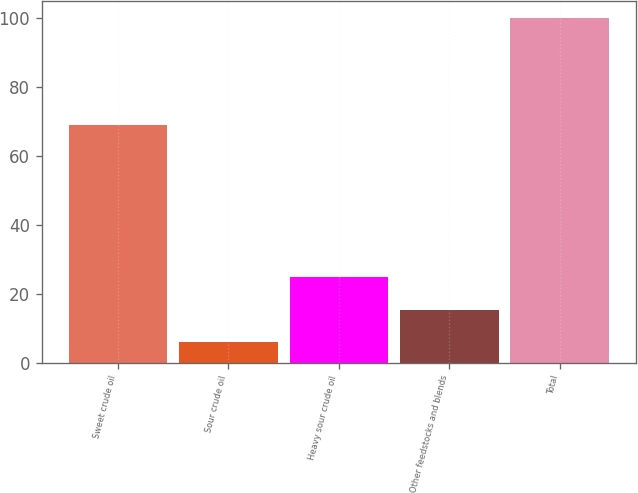<chart> <loc_0><loc_0><loc_500><loc_500><bar_chart><fcel>Sweet crude oil<fcel>Sour crude oil<fcel>Heavy sour crude oil<fcel>Other feedstocks and blends<fcel>Total<nl><fcel>69<fcel>6<fcel>24.8<fcel>15.4<fcel>100<nl></chart> 